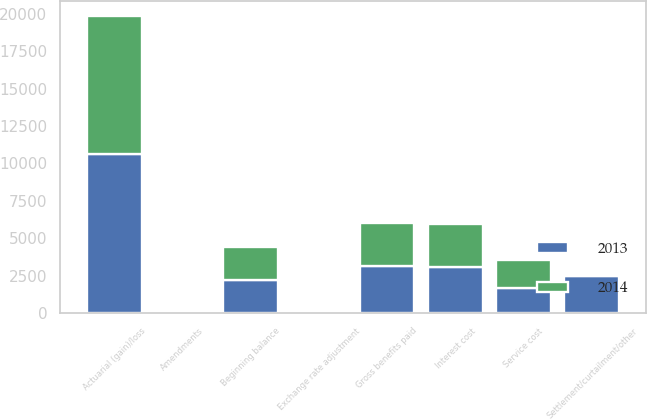Convert chart to OTSL. <chart><loc_0><loc_0><loc_500><loc_500><stacked_bar_chart><ecel><fcel>Beginning balance<fcel>Service cost<fcel>Interest cost<fcel>Amendments<fcel>Actuarial (gain)/loss<fcel>Settlement/curtailment/other<fcel>Gross benefits paid<fcel>Exchange rate adjustment<nl><fcel>2013<fcel>2202<fcel>1661<fcel>3058<fcel>51<fcel>10655<fcel>2518<fcel>3126<fcel>21<nl><fcel>2014<fcel>2202<fcel>1886<fcel>2906<fcel>111<fcel>9205<fcel>81<fcel>2874<fcel>21<nl></chart> 